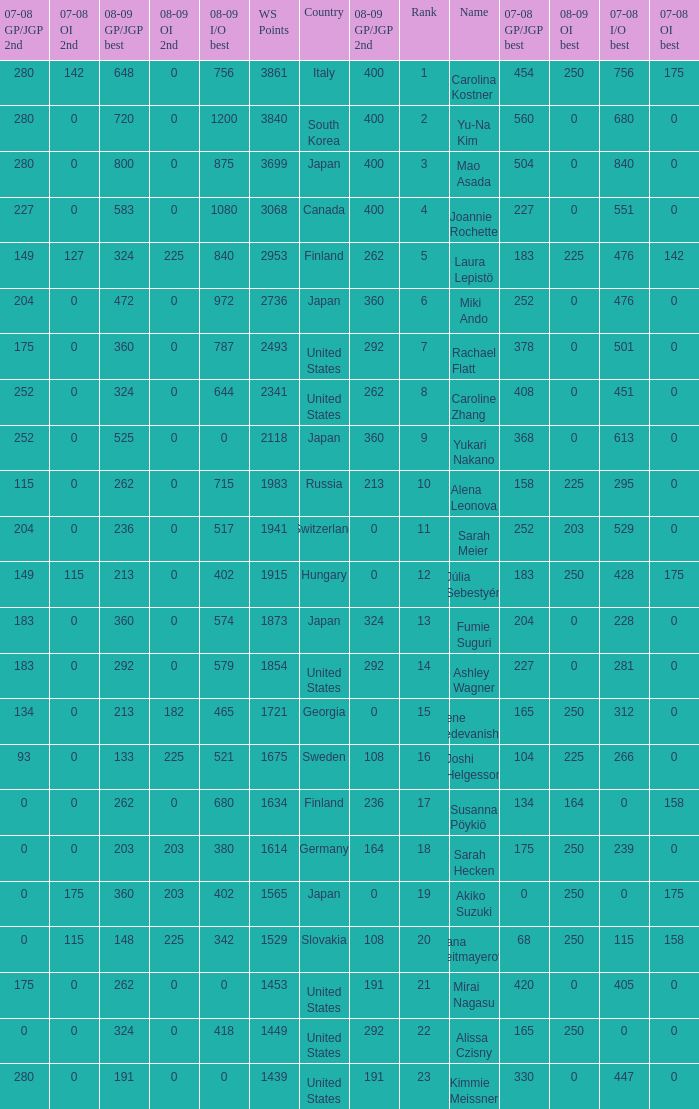What is the total 07-08 gp/jgp 2nd with the name mao asada 280.0. 